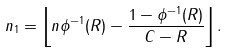<formula> <loc_0><loc_0><loc_500><loc_500>n _ { 1 } = \left \lfloor n \phi ^ { - 1 } ( R ) - \frac { 1 - \phi ^ { - 1 } ( R ) } { C - R } \right \rfloor .</formula> 